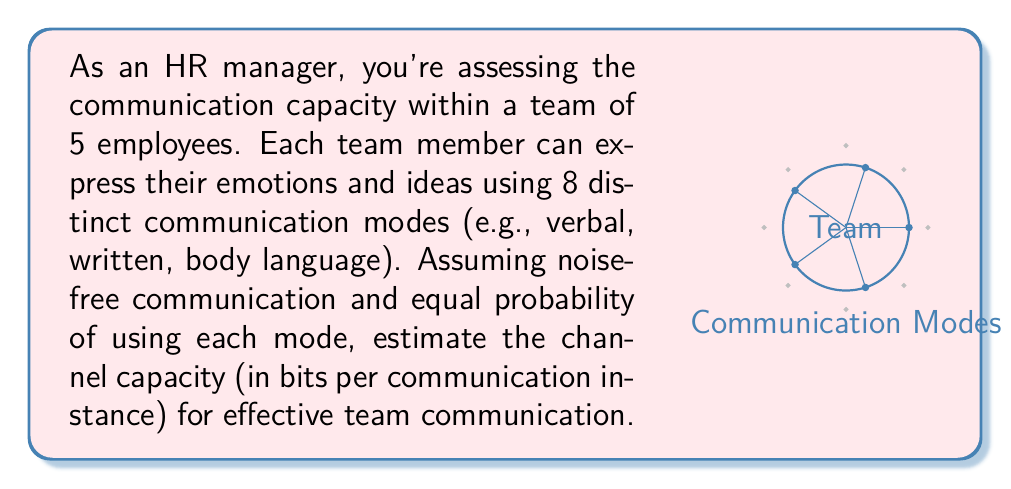Can you solve this math problem? To solve this problem, we'll use the channel capacity formula from information theory:

$$C = \log_2(M)$$

Where:
- $C$ is the channel capacity in bits per symbol (or communication instance)
- $M$ is the number of possible messages (or states)

Steps:
1) In this case, we have 5 team members, each with 8 possible communication modes.

2) The total number of possible states (M) is:
   $$M = 8^5$$
   This represents all possible combinations of communication modes across the 5 team members.

3) Now we can apply the channel capacity formula:
   $$C = \log_2(8^5)$$

4) Using the logarithm power rule: $\log_a(x^n) = n\log_a(x)$
   $$C = 5 \log_2(8)$$

5) $\log_2(8) = 3$ (since $2^3 = 8$)

6) Therefore:
   $$C = 5 \times 3 = 15$$

This means that in each communication instance, the team can effectively communicate up to 15 bits of information.
Answer: 15 bits per communication instance 